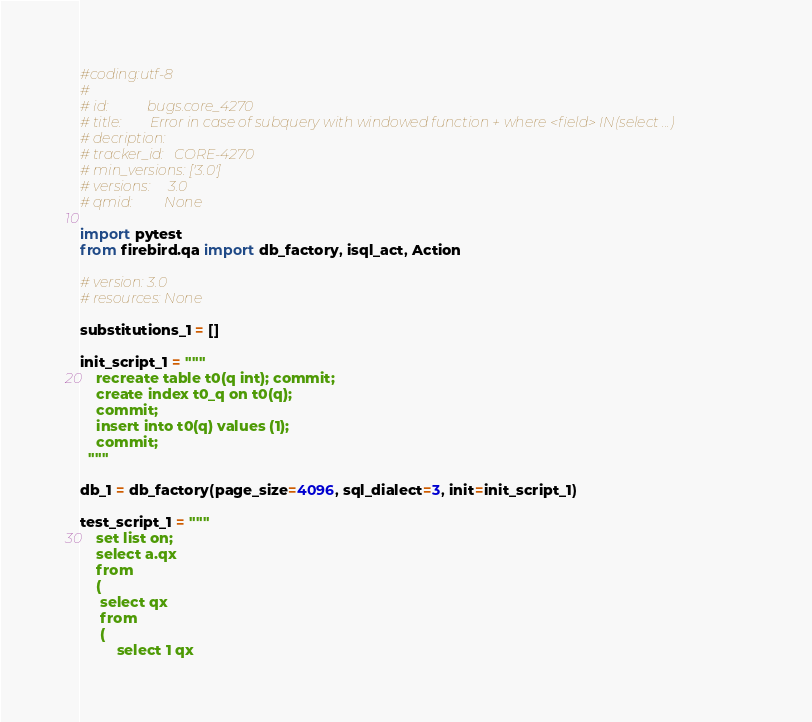Convert code to text. <code><loc_0><loc_0><loc_500><loc_500><_Python_>#coding:utf-8
#
# id:           bugs.core_4270
# title:        Error in case of subquery with windowed function + where <field> IN(select ...)
# decription:   
# tracker_id:   CORE-4270
# min_versions: ['3.0']
# versions:     3.0
# qmid:         None

import pytest
from firebird.qa import db_factory, isql_act, Action

# version: 3.0
# resources: None

substitutions_1 = []

init_script_1 = """
    recreate table t0(q int); commit;
    create index t0_q on t0(q);
    commit;
    insert into t0(q) values (1);
    commit;
  """

db_1 = db_factory(page_size=4096, sql_dialect=3, init=init_script_1)

test_script_1 = """
    set list on;
    select a.qx
    from
    (
     select qx
     from
     (
         select 1 qx</code> 